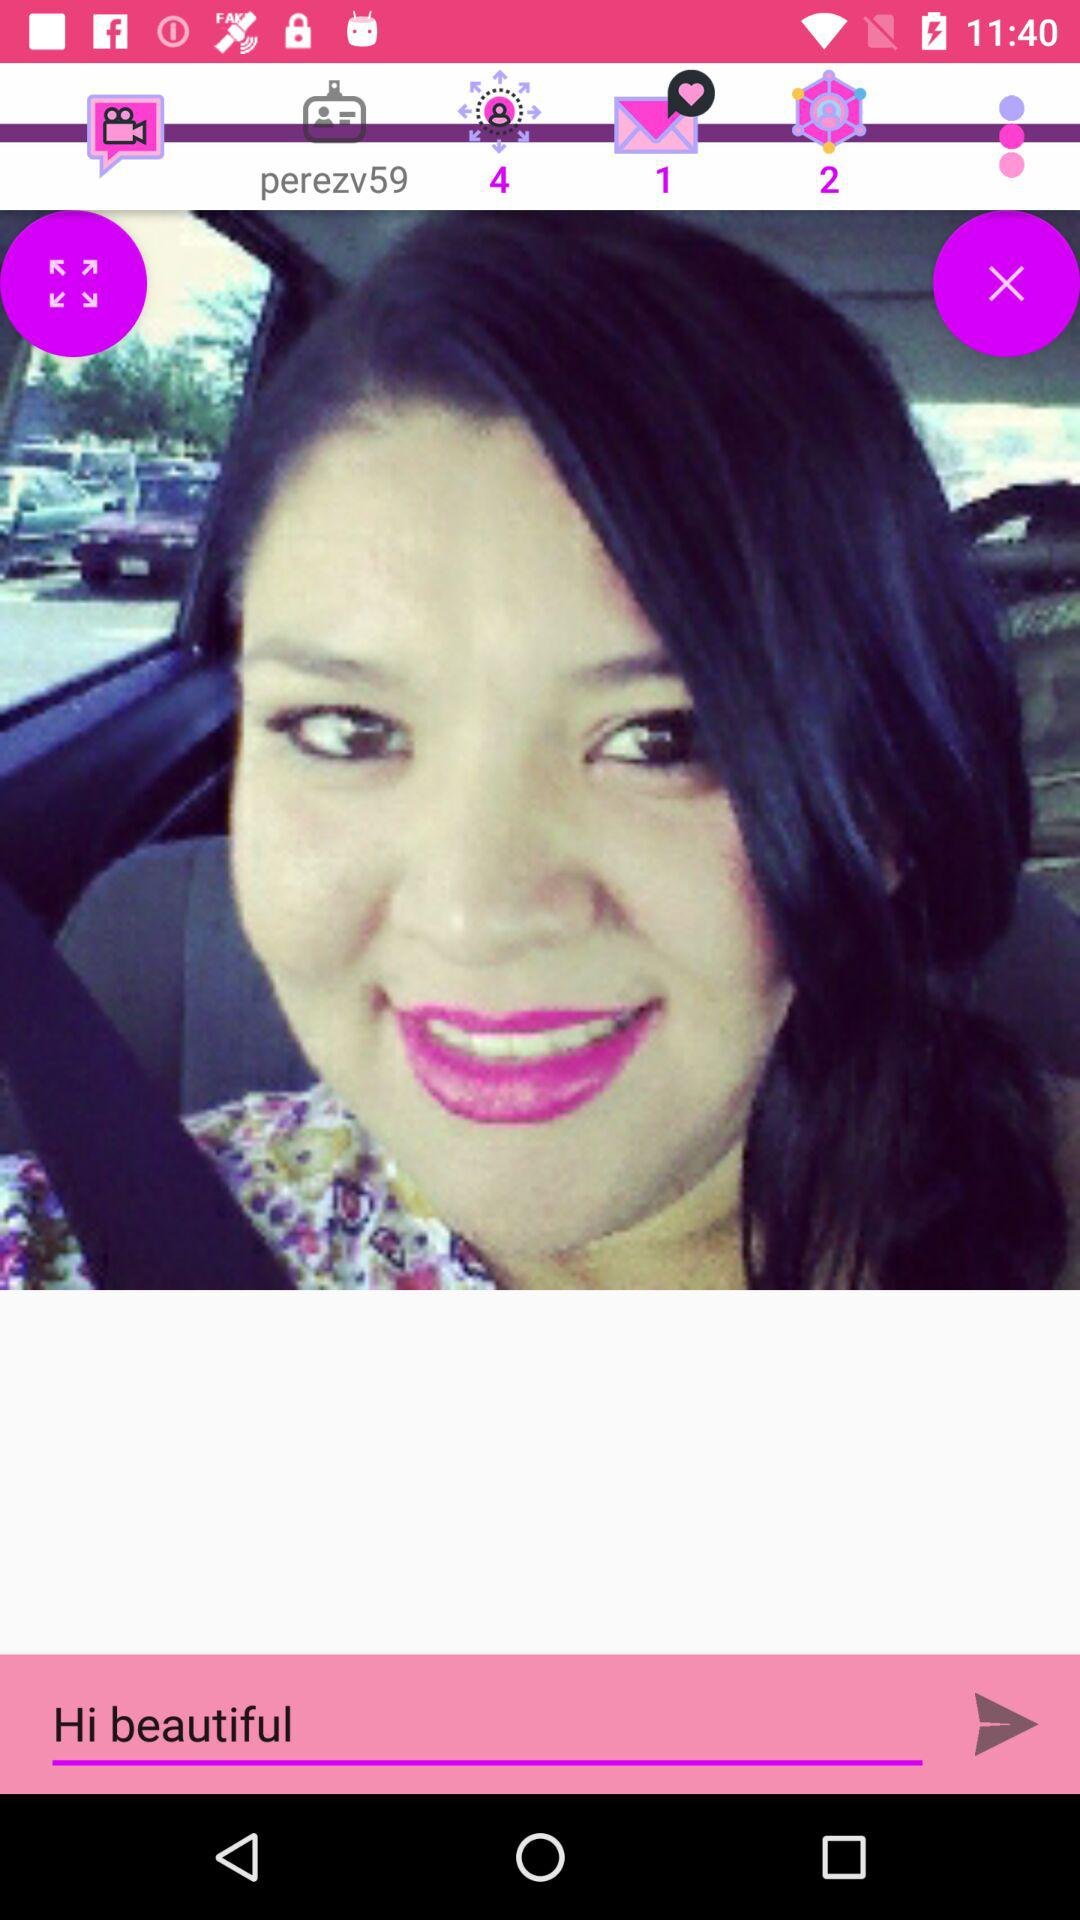What is written in the input field? In the input field, "Hi beautiful" is written. 